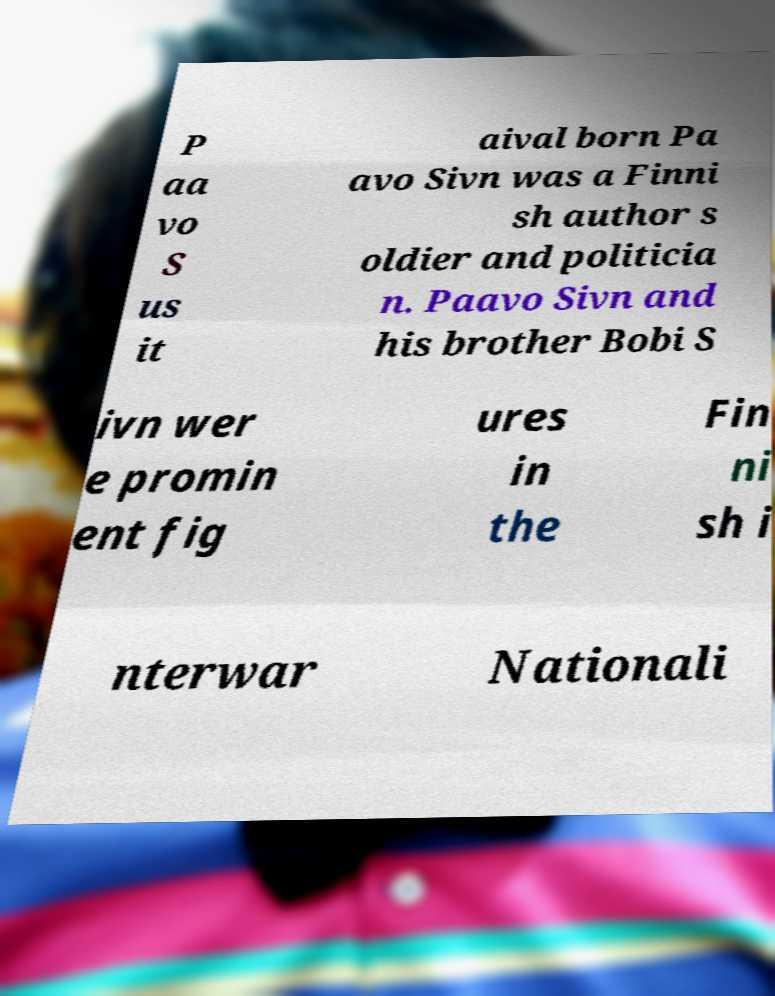Could you extract and type out the text from this image? P aa vo S us it aival born Pa avo Sivn was a Finni sh author s oldier and politicia n. Paavo Sivn and his brother Bobi S ivn wer e promin ent fig ures in the Fin ni sh i nterwar Nationali 